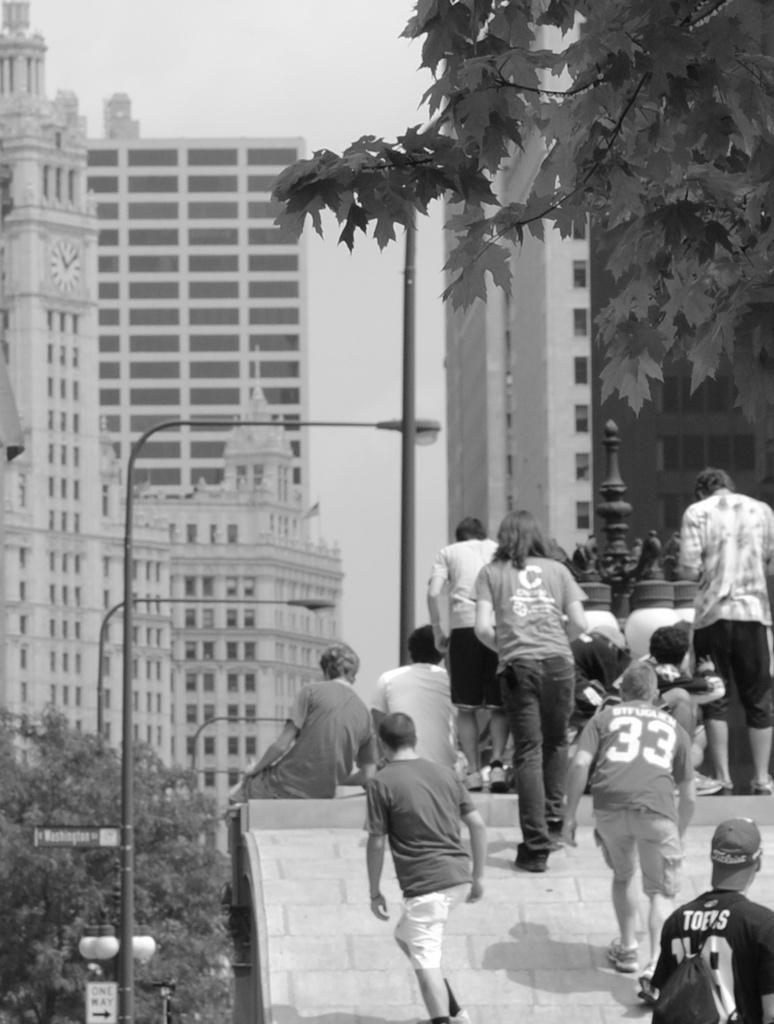<image>
Render a clear and concise summary of the photo. The black and white picture shows a person wearing  number 33 top. 